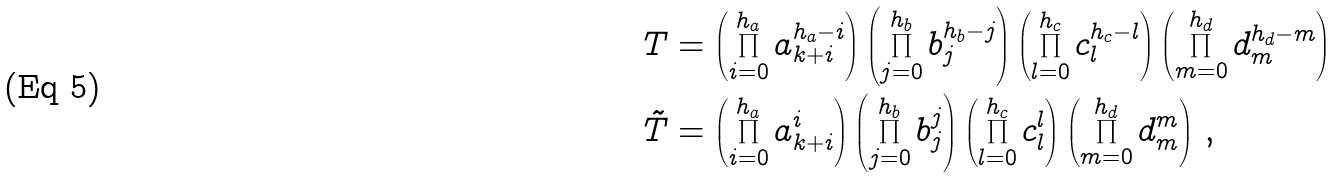Convert formula to latex. <formula><loc_0><loc_0><loc_500><loc_500>T & = \left ( \prod _ { i = 0 } ^ { h _ { a } } a _ { k + i } ^ { h _ { a } - i } \right ) \left ( \prod _ { j = 0 } ^ { h _ { b } } b _ { j } ^ { h _ { b } - j } \right ) \left ( \prod _ { l = 0 } ^ { h _ { c } } c _ { l } ^ { h _ { c } - l } \right ) \left ( \prod _ { m = 0 } ^ { h _ { d } } d _ { m } ^ { h _ { d } - m } \right ) \\ \tilde { T } & = \left ( \prod _ { i = 0 } ^ { h _ { a } } a _ { k + i } ^ { i } \right ) \left ( \prod _ { j = 0 } ^ { h _ { b } } b _ { j } ^ { j } \right ) \left ( \prod _ { l = 0 } ^ { h _ { c } } c _ { l } ^ { l } \right ) \left ( \prod _ { m = 0 } ^ { h _ { d } } d _ { m } ^ { m } \right ) \, ,</formula> 